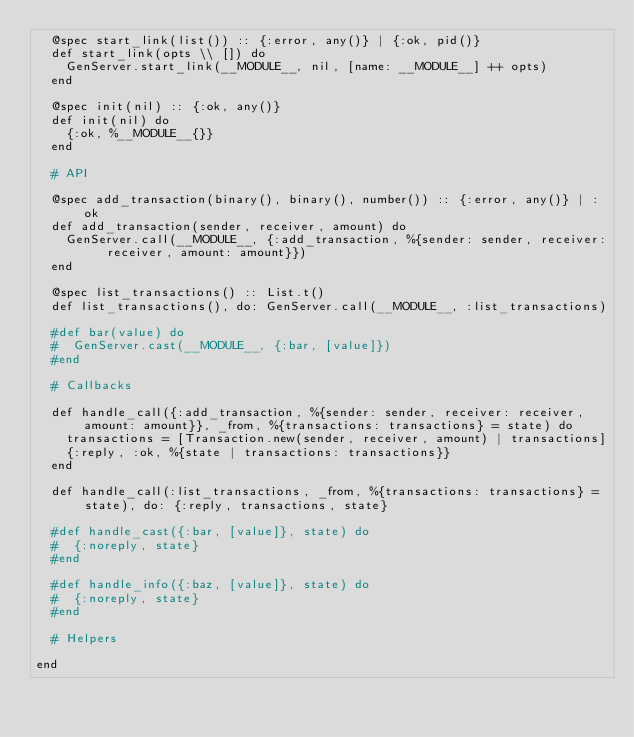<code> <loc_0><loc_0><loc_500><loc_500><_Elixir_>  @spec start_link(list()) :: {:error, any()} | {:ok, pid()}
  def start_link(opts \\ []) do
    GenServer.start_link(__MODULE__, nil, [name: __MODULE__] ++ opts)
  end

  @spec init(nil) :: {:ok, any()}
  def init(nil) do
    {:ok, %__MODULE__{}}
  end

  # API

  @spec add_transaction(binary(), binary(), number()) :: {:error, any()} | :ok
  def add_transaction(sender, receiver, amount) do
    GenServer.call(__MODULE__, {:add_transaction, %{sender: sender, receiver: receiver, amount: amount}})
  end

  @spec list_transactions() :: List.t()
  def list_transactions(), do: GenServer.call(__MODULE__, :list_transactions)

  #def bar(value) do
  #  GenServer.cast(__MODULE__, {:bar, [value]})
  #end

  # Callbacks

  def handle_call({:add_transaction, %{sender: sender, receiver: receiver, amount: amount}}, _from, %{transactions: transactions} = state) do
    transactions = [Transaction.new(sender, receiver, amount) | transactions]
    {:reply, :ok, %{state | transactions: transactions}}
  end

  def handle_call(:list_transactions, _from, %{transactions: transactions} = state), do: {:reply, transactions, state}

  #def handle_cast({:bar, [value]}, state) do
  #  {:noreply, state}
  #end

  #def handle_info({:baz, [value]}, state) do
  #  {:noreply, state}
  #end

  # Helpers

end
</code> 